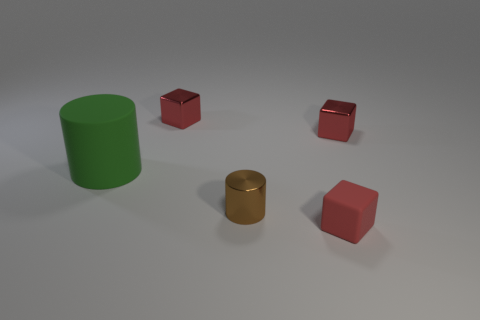Add 4 brown shiny things. How many objects exist? 9 Subtract all cubes. How many objects are left? 2 Subtract all big green rubber cylinders. Subtract all small purple metallic things. How many objects are left? 4 Add 2 small metal things. How many small metal things are left? 5 Add 1 gray balls. How many gray balls exist? 1 Subtract 1 red cubes. How many objects are left? 4 